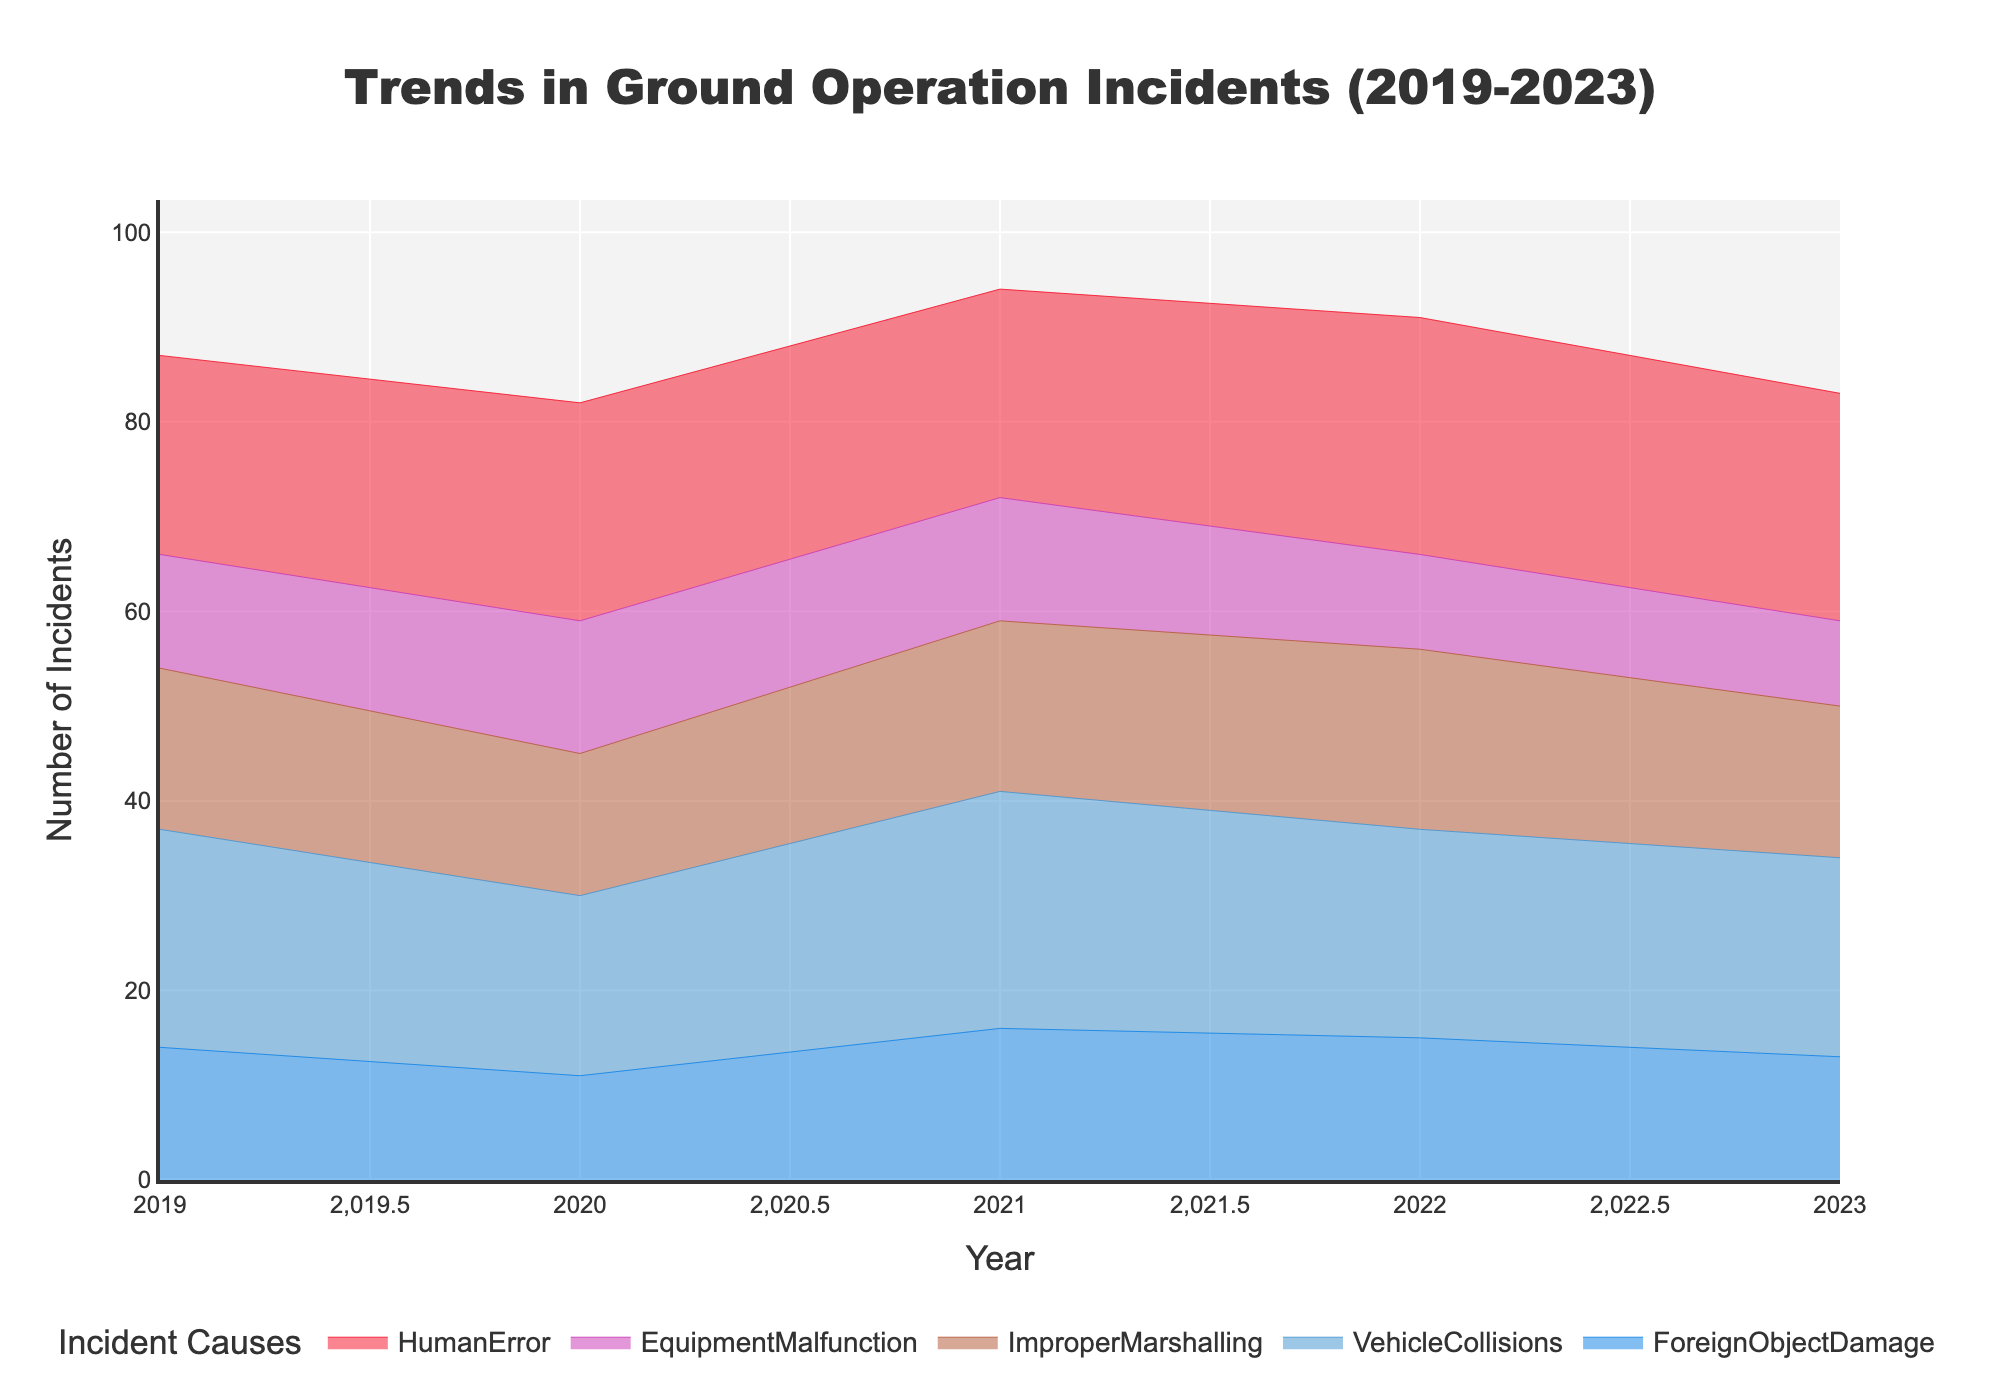Which year had the highest total number of ground operation incidents? Look at each year in the x-axis and sum the number of incidents for each cause. The highest total is for 2022 with Foreign Object Damage (15) + Vehicle Collisions (22) + Improper Marshalling (19) + Equipment Malfunction (10) + Human Error (25) = 91
Answer: 2022 What is the trend of human error incidents over the five-year span? Observe the area corresponding to Human Error from left to right along the x-axis. The numbers go from 21, 23, 22, 25, to 24.
Answer: Increasing Which incident type had the least number of incidents overall in 2023? Observe each segment's value for 2023 on the x-axis. Incident counts for 2023 are Foreign Object Damage (13), Vehicle Collisions (21), Improper Marshalling (16), Equipment Malfunction (9), and Human Error (24).
Answer: Equipment Malfunction In which year did Foreign Object Damage incidents peak? Look at the segment indicating Foreign Object Damage and find the highest point, which is in 2021 with 16 incidents.
Answer: 2021 How did the number of vehicle collisions change from 2020 to 2021? Observe the value for Vehicle Collisions on the x-axis for both 2020 and 2021. The number increased from 19 to 25.
Answer: Increased What is the difference in the number of improper marshalling incidents between 2019 and 2022? Look at the value for Improper Marshalling on the x-axis in 2019 (17) and 2022 (19). Calculate the difference: 19 - 17 = 2.
Answer: 2 How many total incidents were recorded in 2021 for all causes? Sum the values for all causes in 2021: Foreign Object Damage (16) + Vehicle Collisions (25) + Improper Marshalling (18) + Equipment Malfunction (13) + Human Error (22) = 94.
Answer: 94 Compare the number of incidents of Foreign Object Damage between 2019 and 2023. Look at the Foreign Object Damage values for 2019 (14) and 2023 (13). The value decreased by 1.
Answer: Decreased Which cause showed a decreasing trend every year? Observe all the incident causes. Equipment Malfunction shows a consistent decrease from 12, 14, 13, 10 to 9.
Answer: Equipment Malfunction 